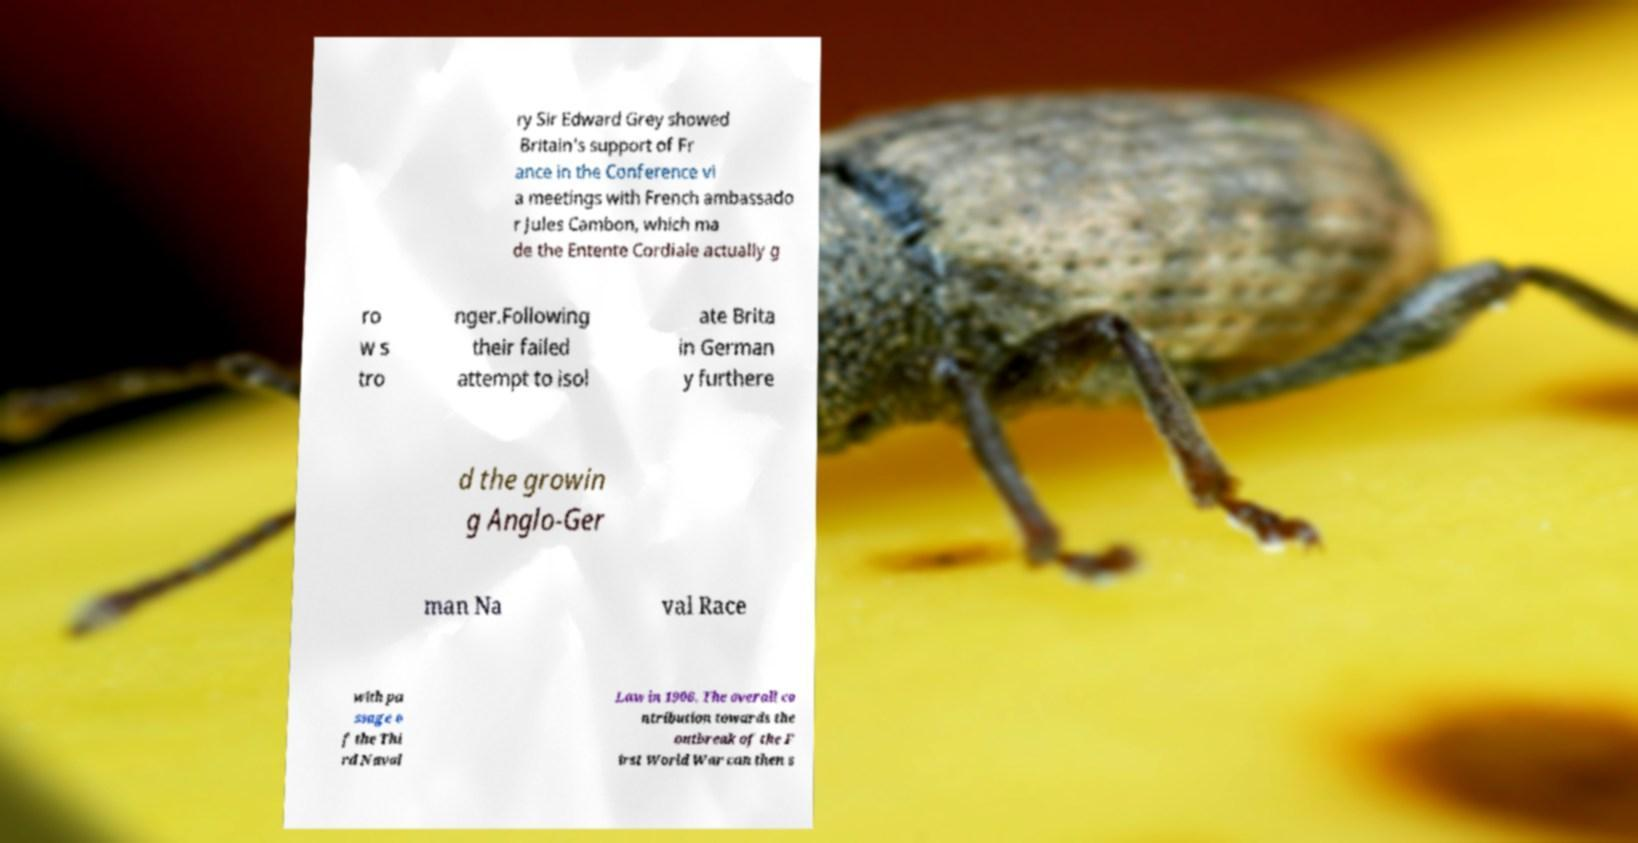There's text embedded in this image that I need extracted. Can you transcribe it verbatim? ry Sir Edward Grey showed Britain's support of Fr ance in the Conference vi a meetings with French ambassado r Jules Cambon, which ma de the Entente Cordiale actually g ro w s tro nger.Following their failed attempt to isol ate Brita in German y furthere d the growin g Anglo-Ger man Na val Race with pa ssage o f the Thi rd Naval Law in 1906. The overall co ntribution towards the outbreak of the F irst World War can then s 